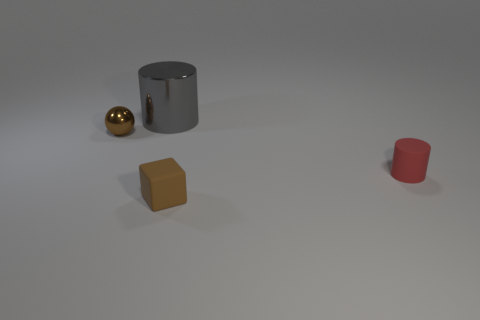Add 2 red matte cylinders. How many objects exist? 6 Subtract all blocks. How many objects are left? 3 Subtract all tiny cylinders. Subtract all brown spheres. How many objects are left? 2 Add 4 large things. How many large things are left? 5 Add 4 tiny balls. How many tiny balls exist? 5 Subtract 1 gray cylinders. How many objects are left? 3 